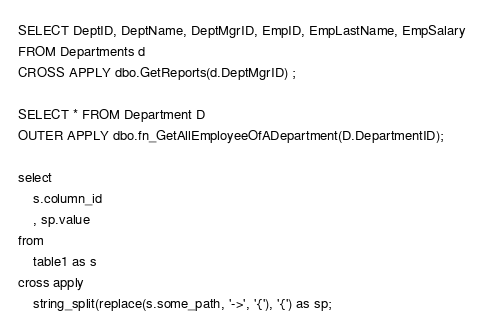Convert code to text. <code><loc_0><loc_0><loc_500><loc_500><_SQL_>SELECT DeptID, DeptName, DeptMgrID, EmpID, EmpLastName, EmpSalary
FROM Departments d
CROSS APPLY dbo.GetReports(d.DeptMgrID) ;

SELECT * FROM Department D
OUTER APPLY dbo.fn_GetAllEmployeeOfADepartment(D.DepartmentID);

select
	s.column_id
	, sp.value
from
	table1 as s
cross apply
	string_split(replace(s.some_path, '->', '{'), '{') as sp;
</code> 